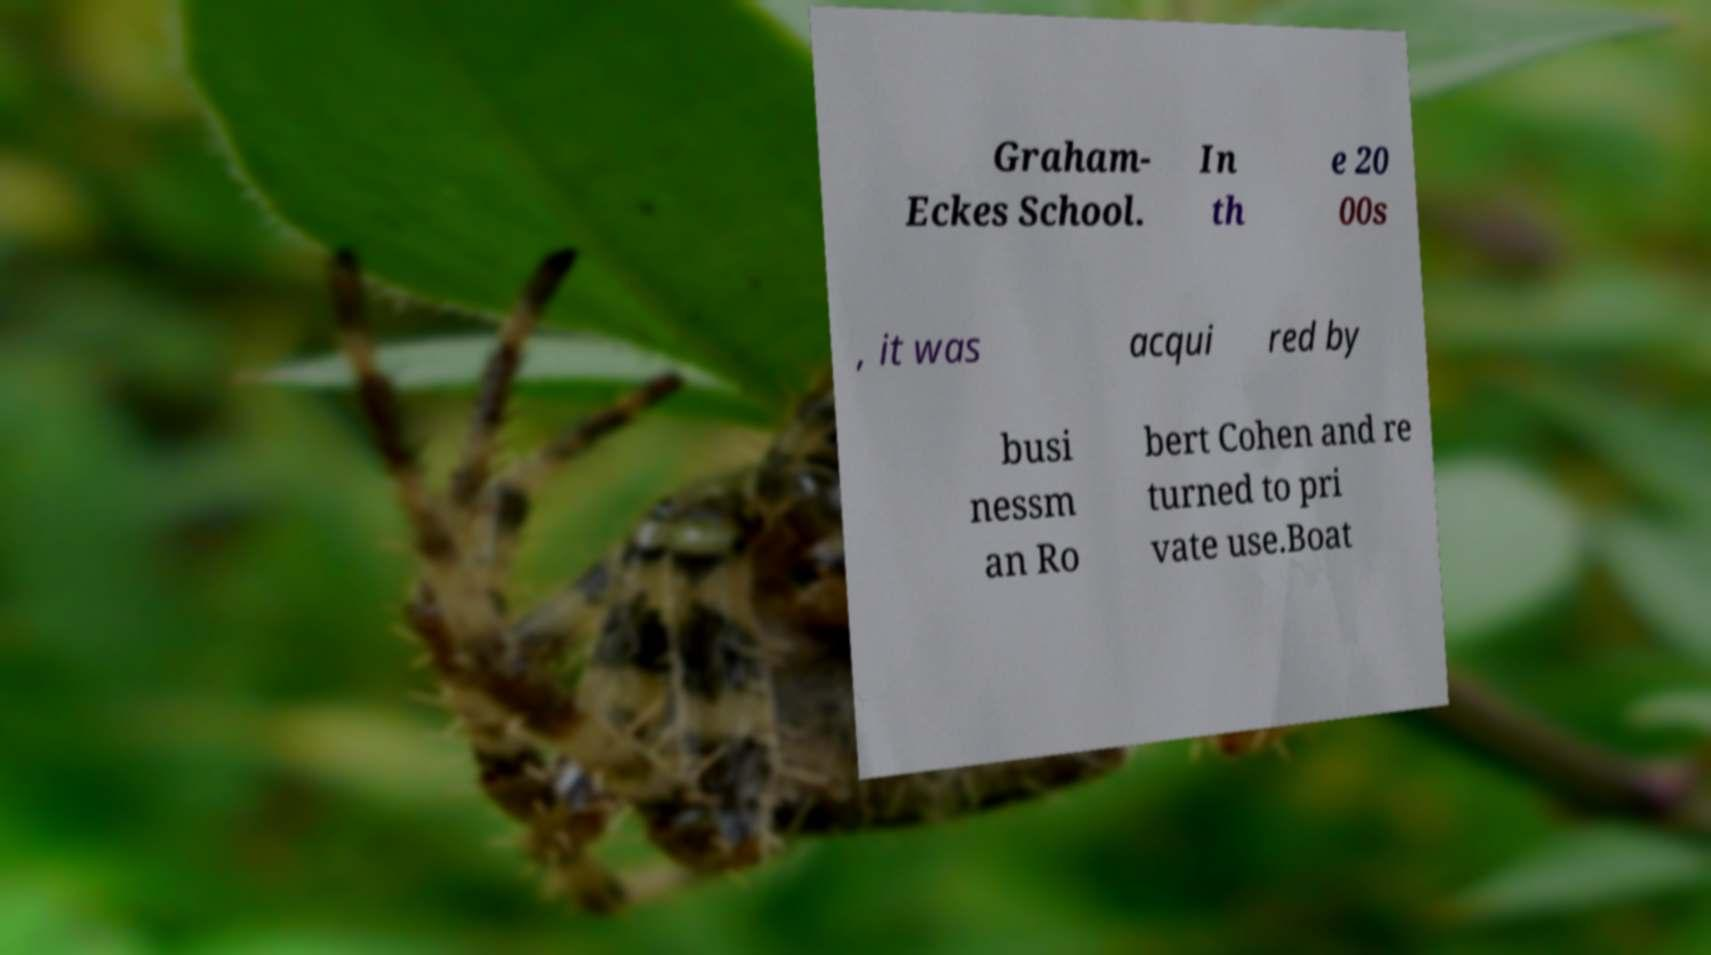Can you read and provide the text displayed in the image?This photo seems to have some interesting text. Can you extract and type it out for me? Graham- Eckes School. In th e 20 00s , it was acqui red by busi nessm an Ro bert Cohen and re turned to pri vate use.Boat 